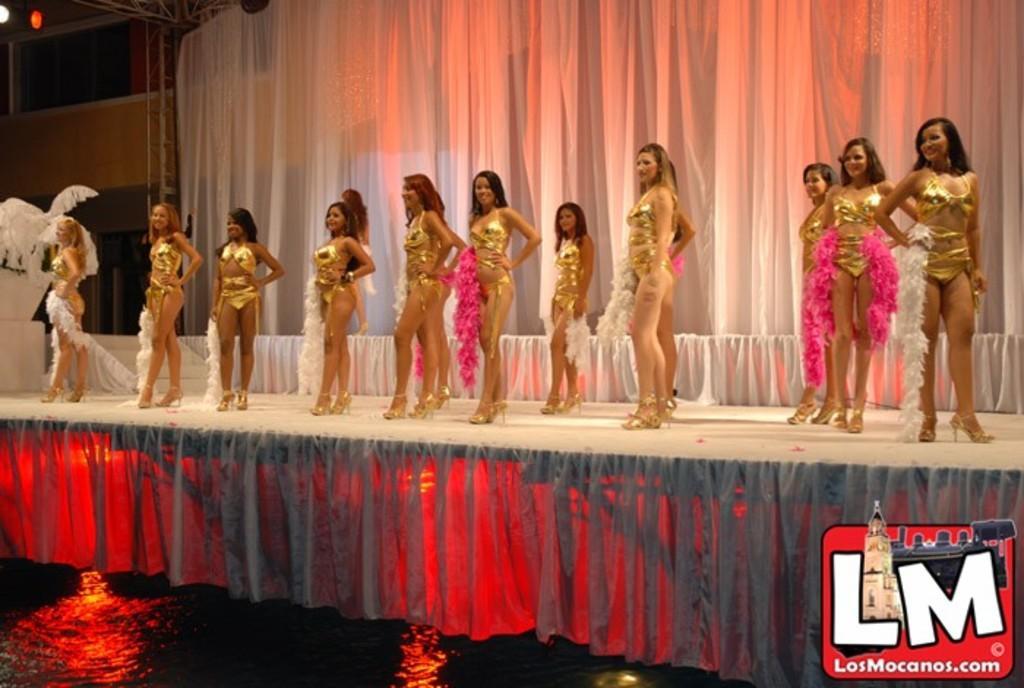Can you describe this image briefly? In this image there are women with same costume on the stage. In the background we can see white curtain. At the bottom there is a logo. On the left there are windows. 